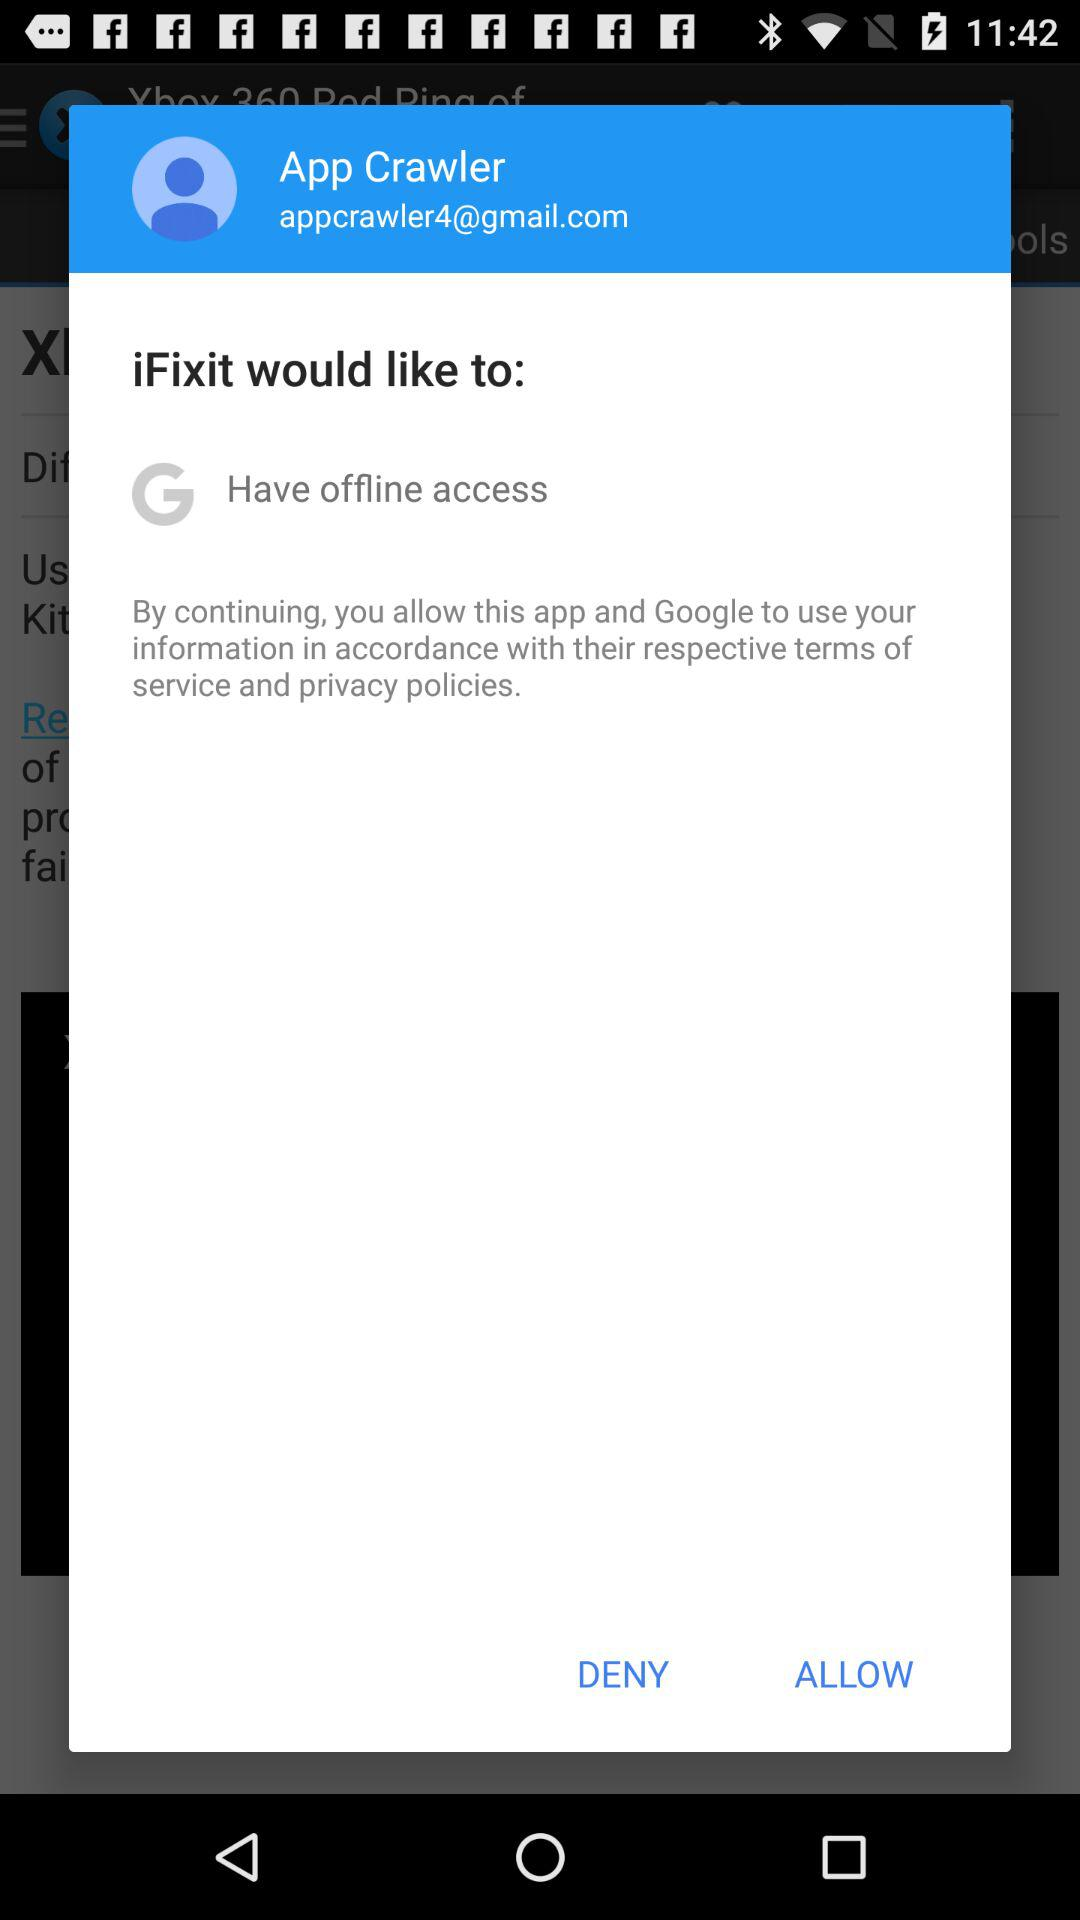What is the name of the user? The name of the user is App Crawler. 